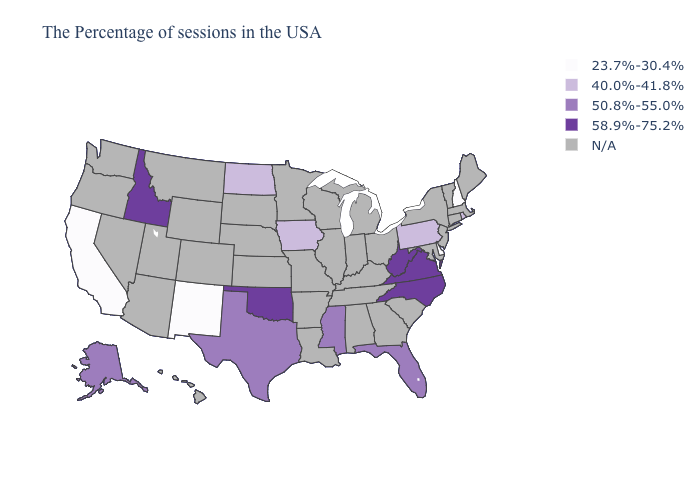What is the value of Louisiana?
Quick response, please. N/A. Which states hav the highest value in the MidWest?
Be succinct. Iowa, North Dakota. Name the states that have a value in the range N/A?
Keep it brief. Maine, Massachusetts, Vermont, Connecticut, New York, New Jersey, Maryland, South Carolina, Ohio, Georgia, Michigan, Kentucky, Indiana, Alabama, Tennessee, Wisconsin, Illinois, Louisiana, Missouri, Arkansas, Minnesota, Kansas, Nebraska, South Dakota, Wyoming, Colorado, Utah, Montana, Arizona, Nevada, Washington, Oregon, Hawaii. What is the value of Arkansas?
Write a very short answer. N/A. Is the legend a continuous bar?
Answer briefly. No. Name the states that have a value in the range 50.8%-55.0%?
Concise answer only. Florida, Mississippi, Texas, Alaska. Name the states that have a value in the range 58.9%-75.2%?
Quick response, please. Virginia, North Carolina, West Virginia, Oklahoma, Idaho. What is the value of Massachusetts?
Short answer required. N/A. What is the value of Maryland?
Keep it brief. N/A. Which states hav the highest value in the Northeast?
Give a very brief answer. Rhode Island, Pennsylvania. Name the states that have a value in the range 23.7%-30.4%?
Answer briefly. New Hampshire, Delaware, New Mexico, California. What is the value of Massachusetts?
Keep it brief. N/A. Among the states that border New Jersey , which have the lowest value?
Short answer required. Delaware. What is the lowest value in the USA?
Short answer required. 23.7%-30.4%. 